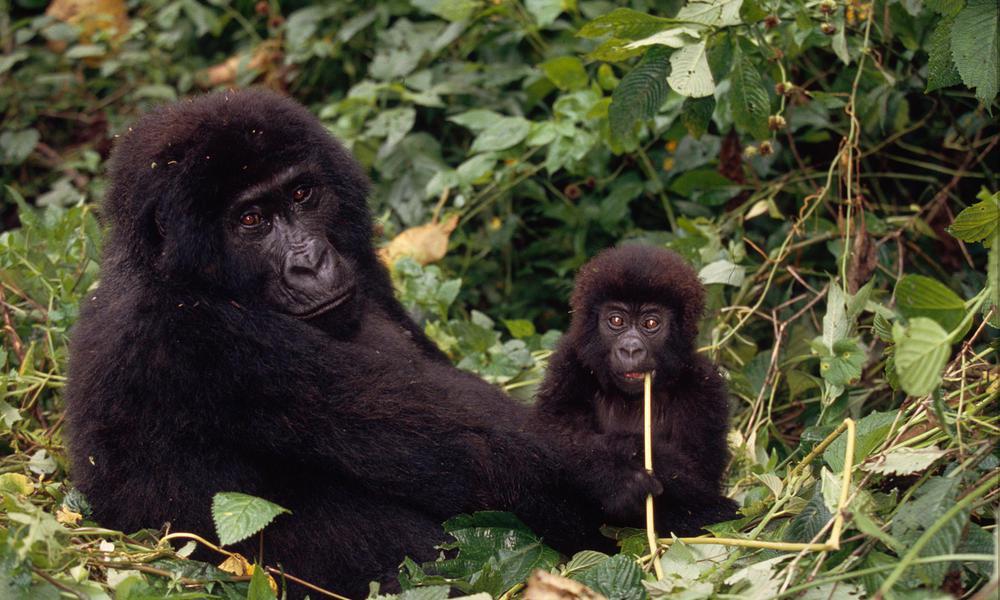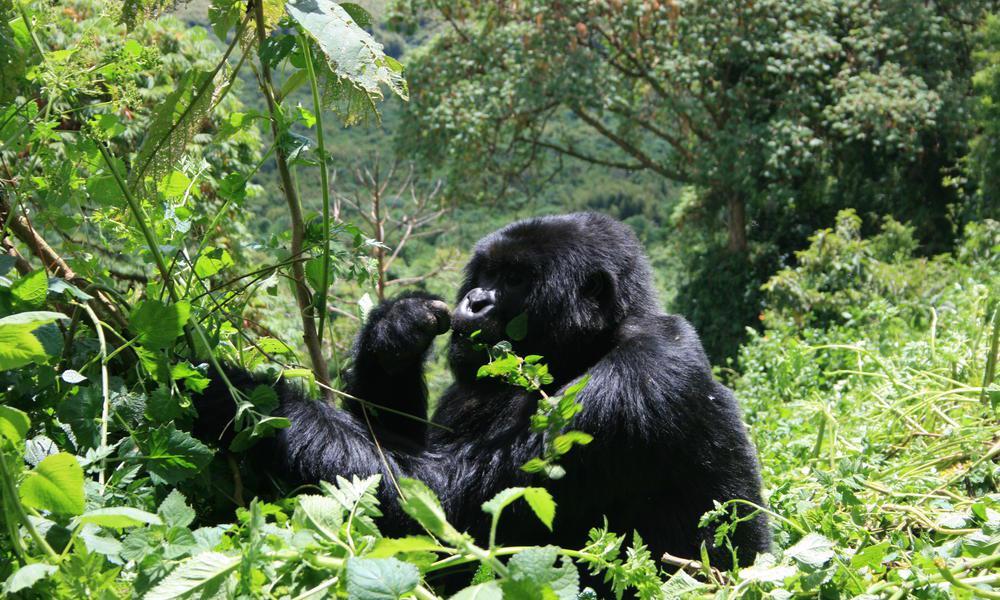The first image is the image on the left, the second image is the image on the right. Given the left and right images, does the statement "There are no more than five gorillas." hold true? Answer yes or no. Yes. The first image is the image on the left, the second image is the image on the right. Examine the images to the left and right. Is the description "There are at least 6 gorillas in the right image." accurate? Answer yes or no. No. 